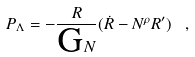<formula> <loc_0><loc_0><loc_500><loc_500>P _ { \Lambda } = - \frac { R } { \text {G} N } ( \dot { R } - { N } ^ { \rho } R ^ { \prime } ) \ ,</formula> 